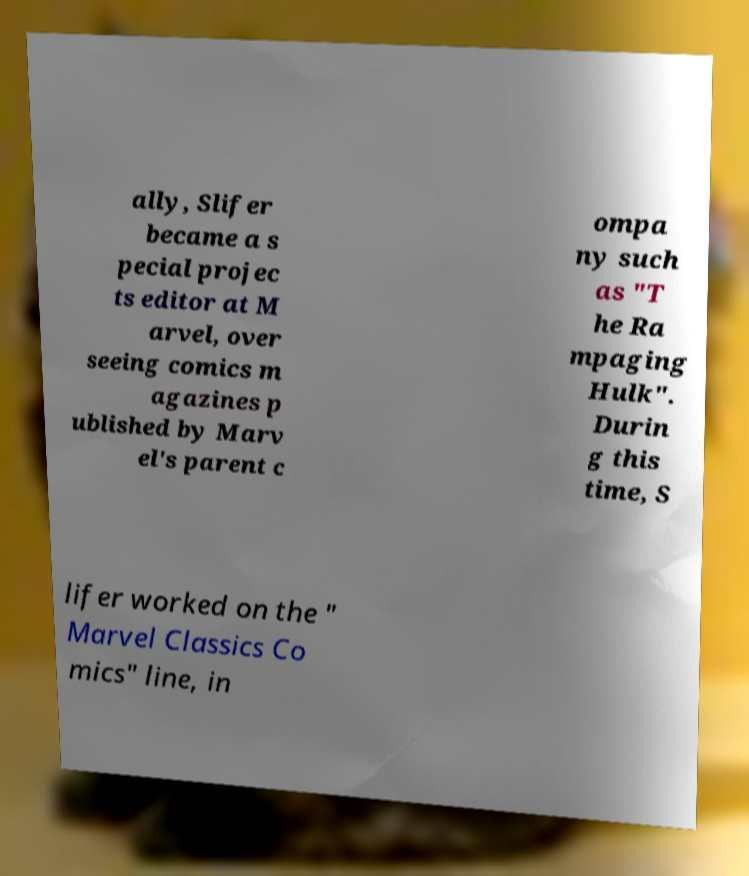Could you assist in decoding the text presented in this image and type it out clearly? ally, Slifer became a s pecial projec ts editor at M arvel, over seeing comics m agazines p ublished by Marv el's parent c ompa ny such as "T he Ra mpaging Hulk". Durin g this time, S lifer worked on the " Marvel Classics Co mics" line, in 